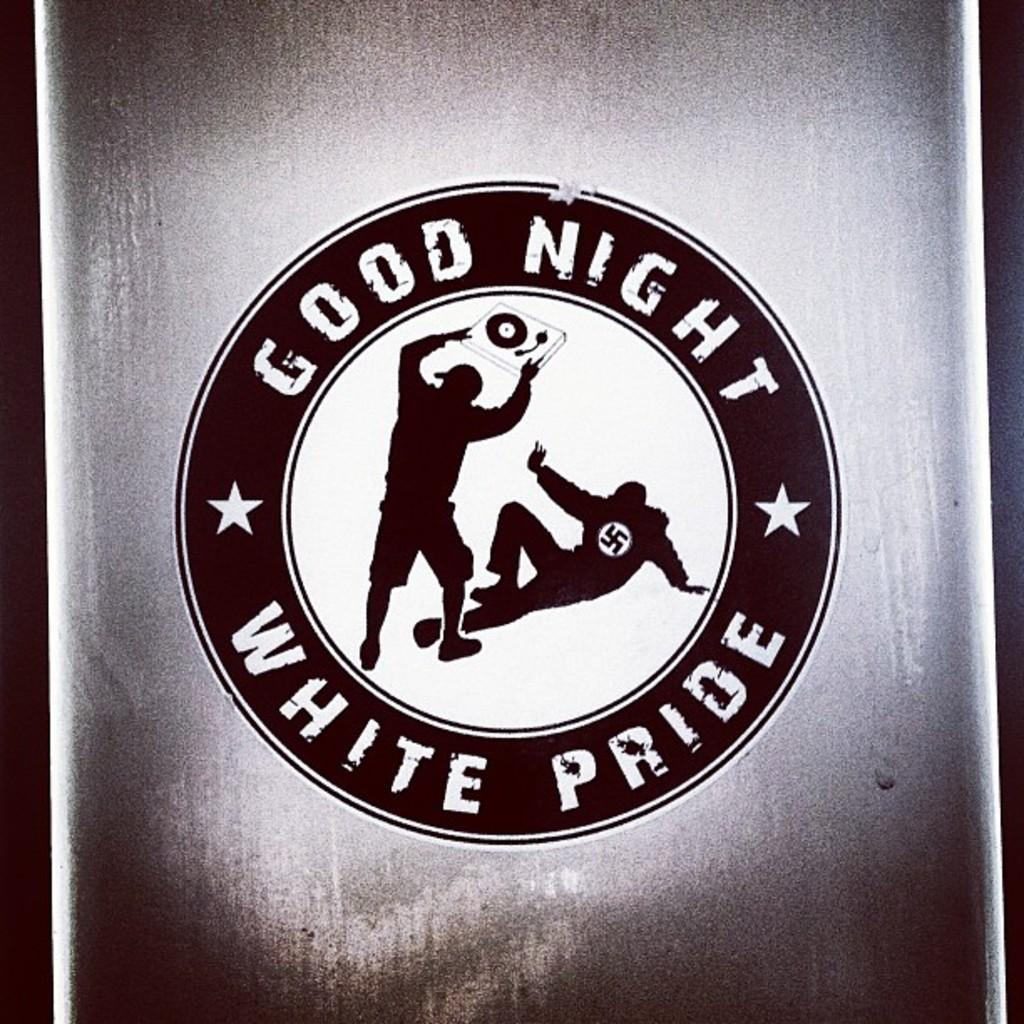<image>
Summarize the visual content of the image. A poster on a wall that shows a large circle with 2 people in the center that says GOOD NIGHT WHITE PRIDE. 